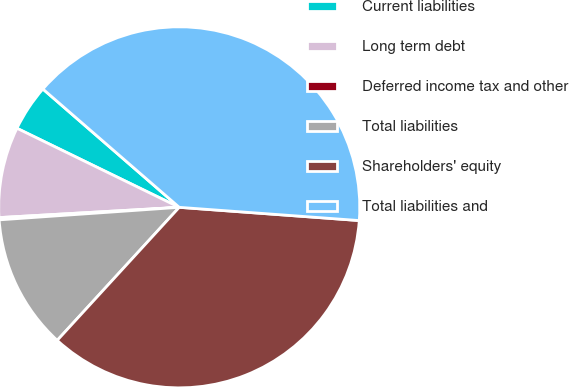<chart> <loc_0><loc_0><loc_500><loc_500><pie_chart><fcel>Current liabilities<fcel>Long term debt<fcel>Deferred income tax and other<fcel>Total liabilities<fcel>Shareholders' equity<fcel>Total liabilities and<nl><fcel>4.16%<fcel>8.12%<fcel>0.2%<fcel>12.08%<fcel>35.64%<fcel>39.79%<nl></chart> 